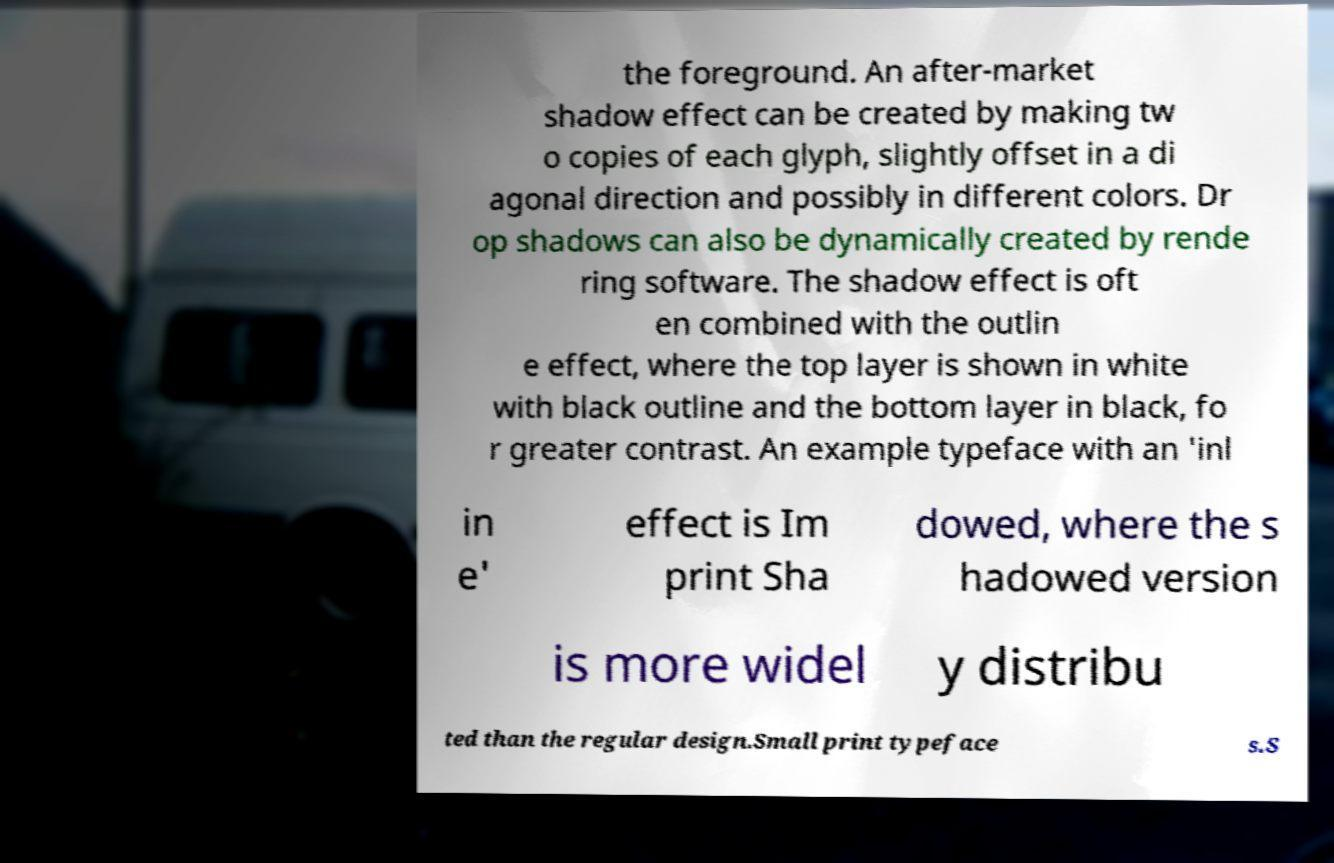Could you assist in decoding the text presented in this image and type it out clearly? the foreground. An after-market shadow effect can be created by making tw o copies of each glyph, slightly offset in a di agonal direction and possibly in different colors. Dr op shadows can also be dynamically created by rende ring software. The shadow effect is oft en combined with the outlin e effect, where the top layer is shown in white with black outline and the bottom layer in black, fo r greater contrast. An example typeface with an 'inl in e' effect is Im print Sha dowed, where the s hadowed version is more widel y distribu ted than the regular design.Small print typeface s.S 